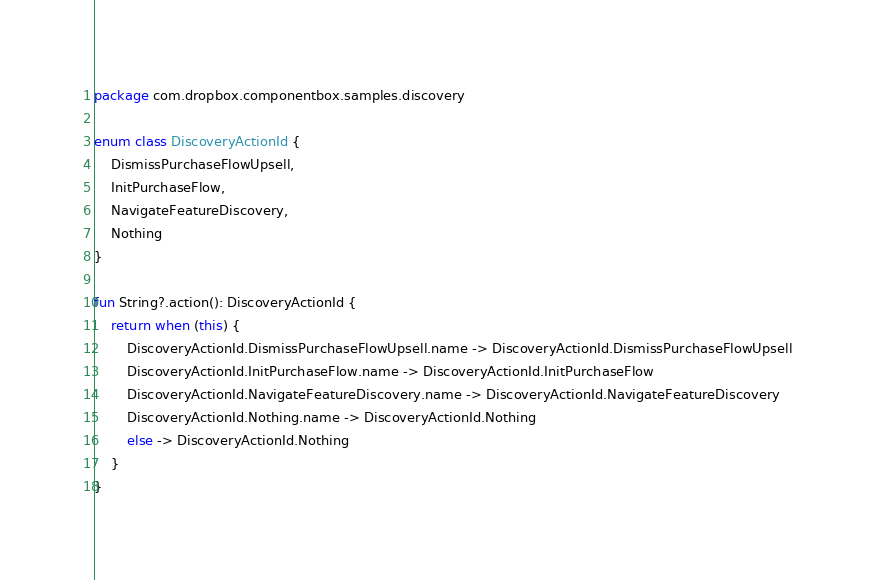<code> <loc_0><loc_0><loc_500><loc_500><_Kotlin_>package com.dropbox.componentbox.samples.discovery

enum class DiscoveryActionId {
    DismissPurchaseFlowUpsell,
    InitPurchaseFlow,
    NavigateFeatureDiscovery,
    Nothing
}

fun String?.action(): DiscoveryActionId {
    return when (this) {
        DiscoveryActionId.DismissPurchaseFlowUpsell.name -> DiscoveryActionId.DismissPurchaseFlowUpsell
        DiscoveryActionId.InitPurchaseFlow.name -> DiscoveryActionId.InitPurchaseFlow
        DiscoveryActionId.NavigateFeatureDiscovery.name -> DiscoveryActionId.NavigateFeatureDiscovery
        DiscoveryActionId.Nothing.name -> DiscoveryActionId.Nothing
        else -> DiscoveryActionId.Nothing
    }
}</code> 